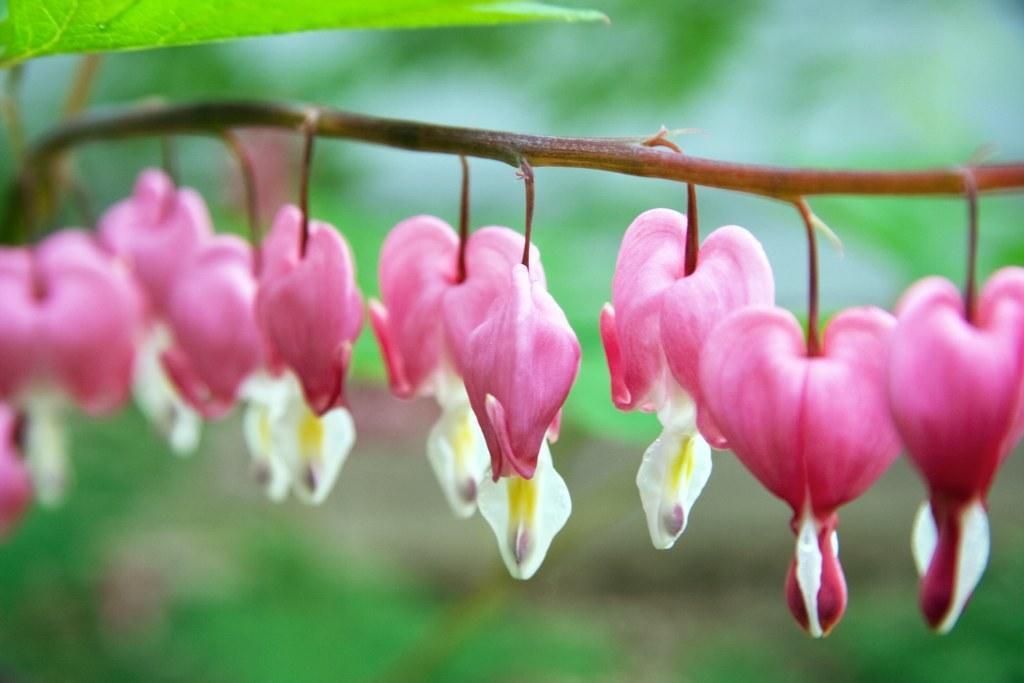How would you summarize this image in a sentence or two? In this picture we can see the flowers in the plant. At the top we can see the leaf. 